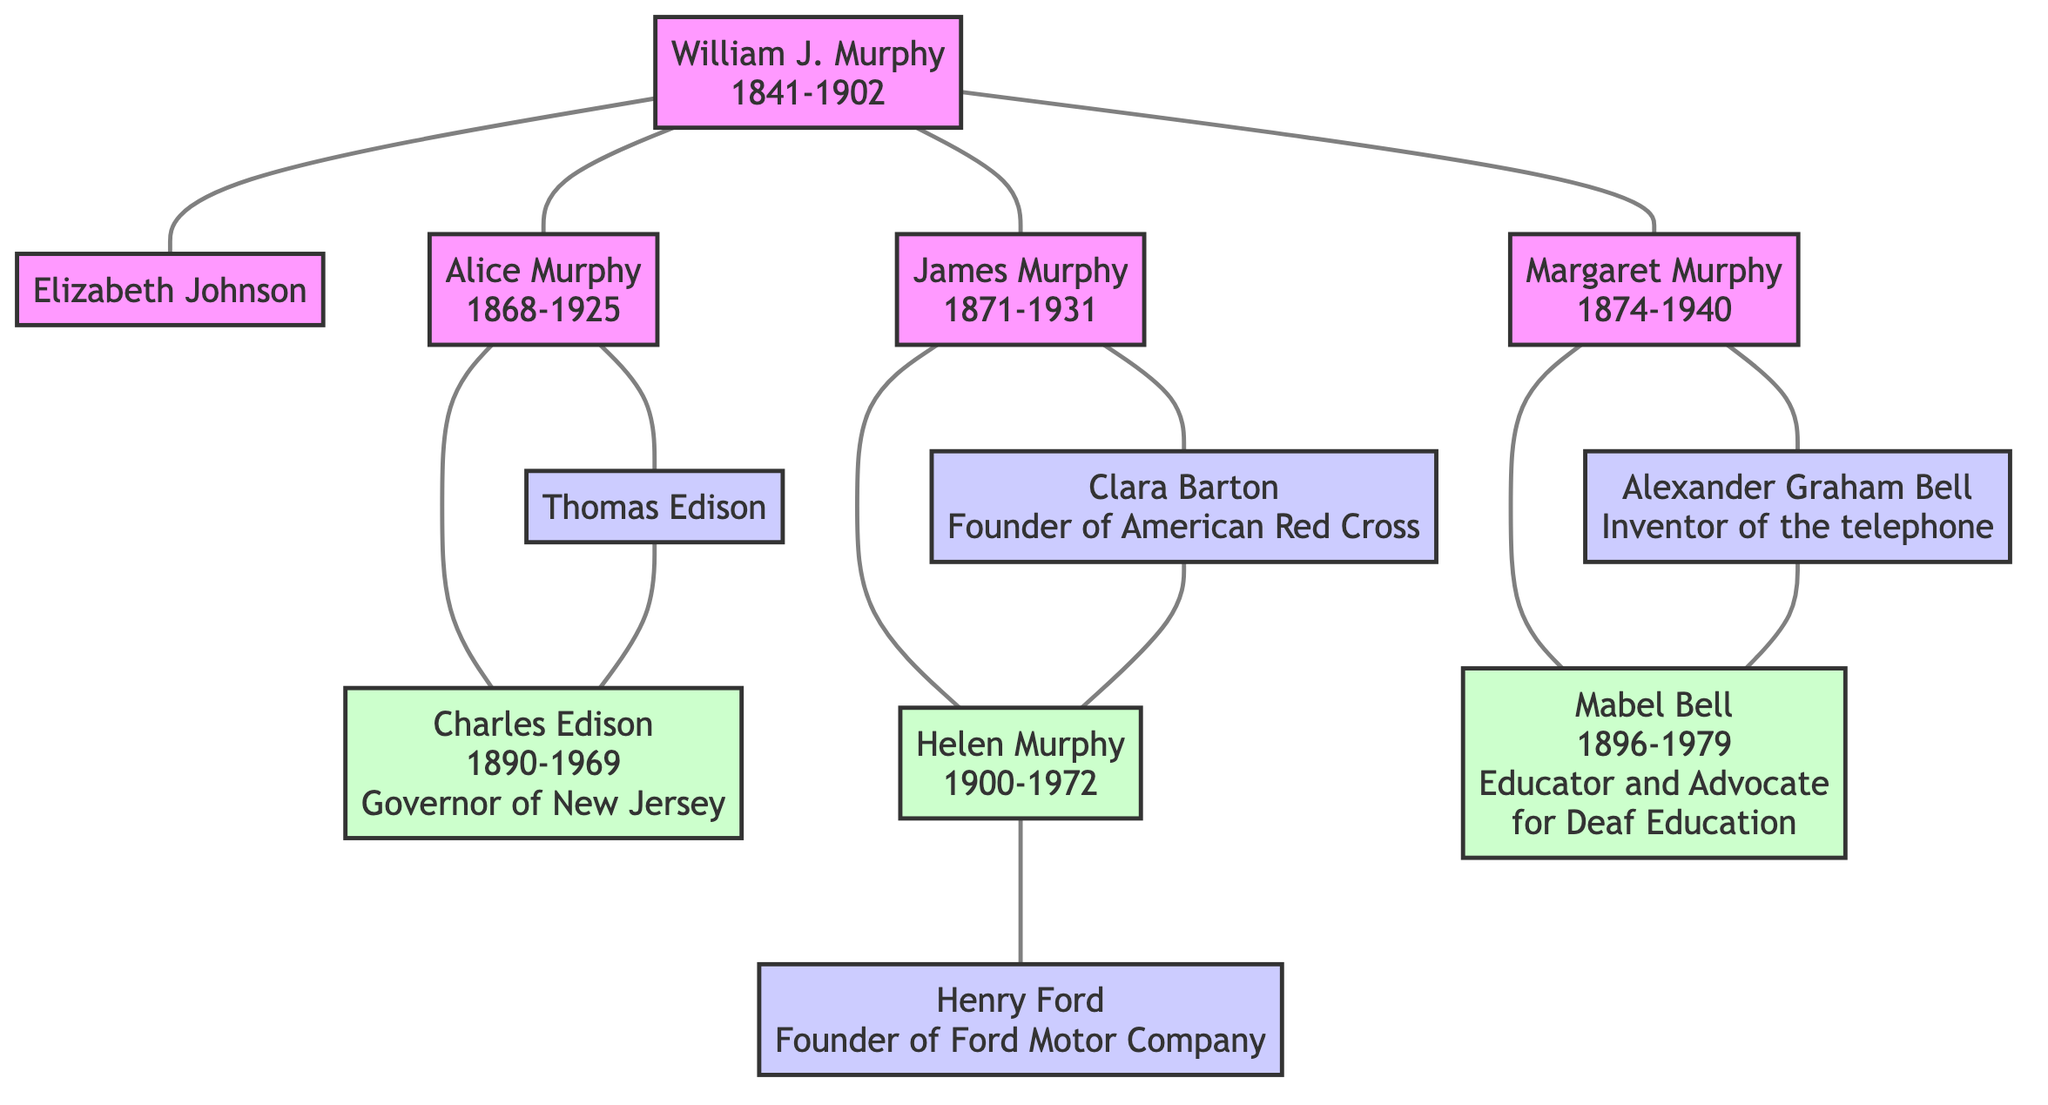What is the birth year of William J. Murphy? The diagram shows that William J. Murphy was born in 1841.
Answer: 1841 How many children did William J. Murphy have? The diagram lists three children (Alice Murphy, James Murphy, and Margaret Murphy) under William J. Murphy.
Answer: 3 Who was the spouse of James Murphy? The diagram indicates that the spouse of James Murphy is Clara Barton.
Answer: Clara Barton Who is the founder of the American Red Cross? The diagram states that Clara Barton, who is the spouse of James Murphy, is the founder of the American Red Cross.
Answer: Clara Barton What is the relationship of Charles Edison to Alice Murphy? The diagram shows that Charles Edison is the child of Alice Murphy and Thomas Edison, making him their son.
Answer: Son Which significant historical figure is connected to Helen Murphy? The diagram indicates that Helen Murphy is the spouse of Henry Ford, who is a significant historical figure as the founder of Ford Motor Company.
Answer: Henry Ford How is Mabel Bell related to Margaret Murphy? The diagram states that Mabel Bell is the child of Margaret Murphy and Alexander Graham Bell, making her the daughter of Margaret Murphy.
Answer: Daughter What year did Alice Murphy die? According to the diagram, Alice Murphy died in 1925.
Answer: 1925 Who are the children of Margaret Murphy? The diagram shows that Mabel Bell is the only child listed under Margaret Murphy and Alexander Graham Bell.
Answer: Mabel Bell 